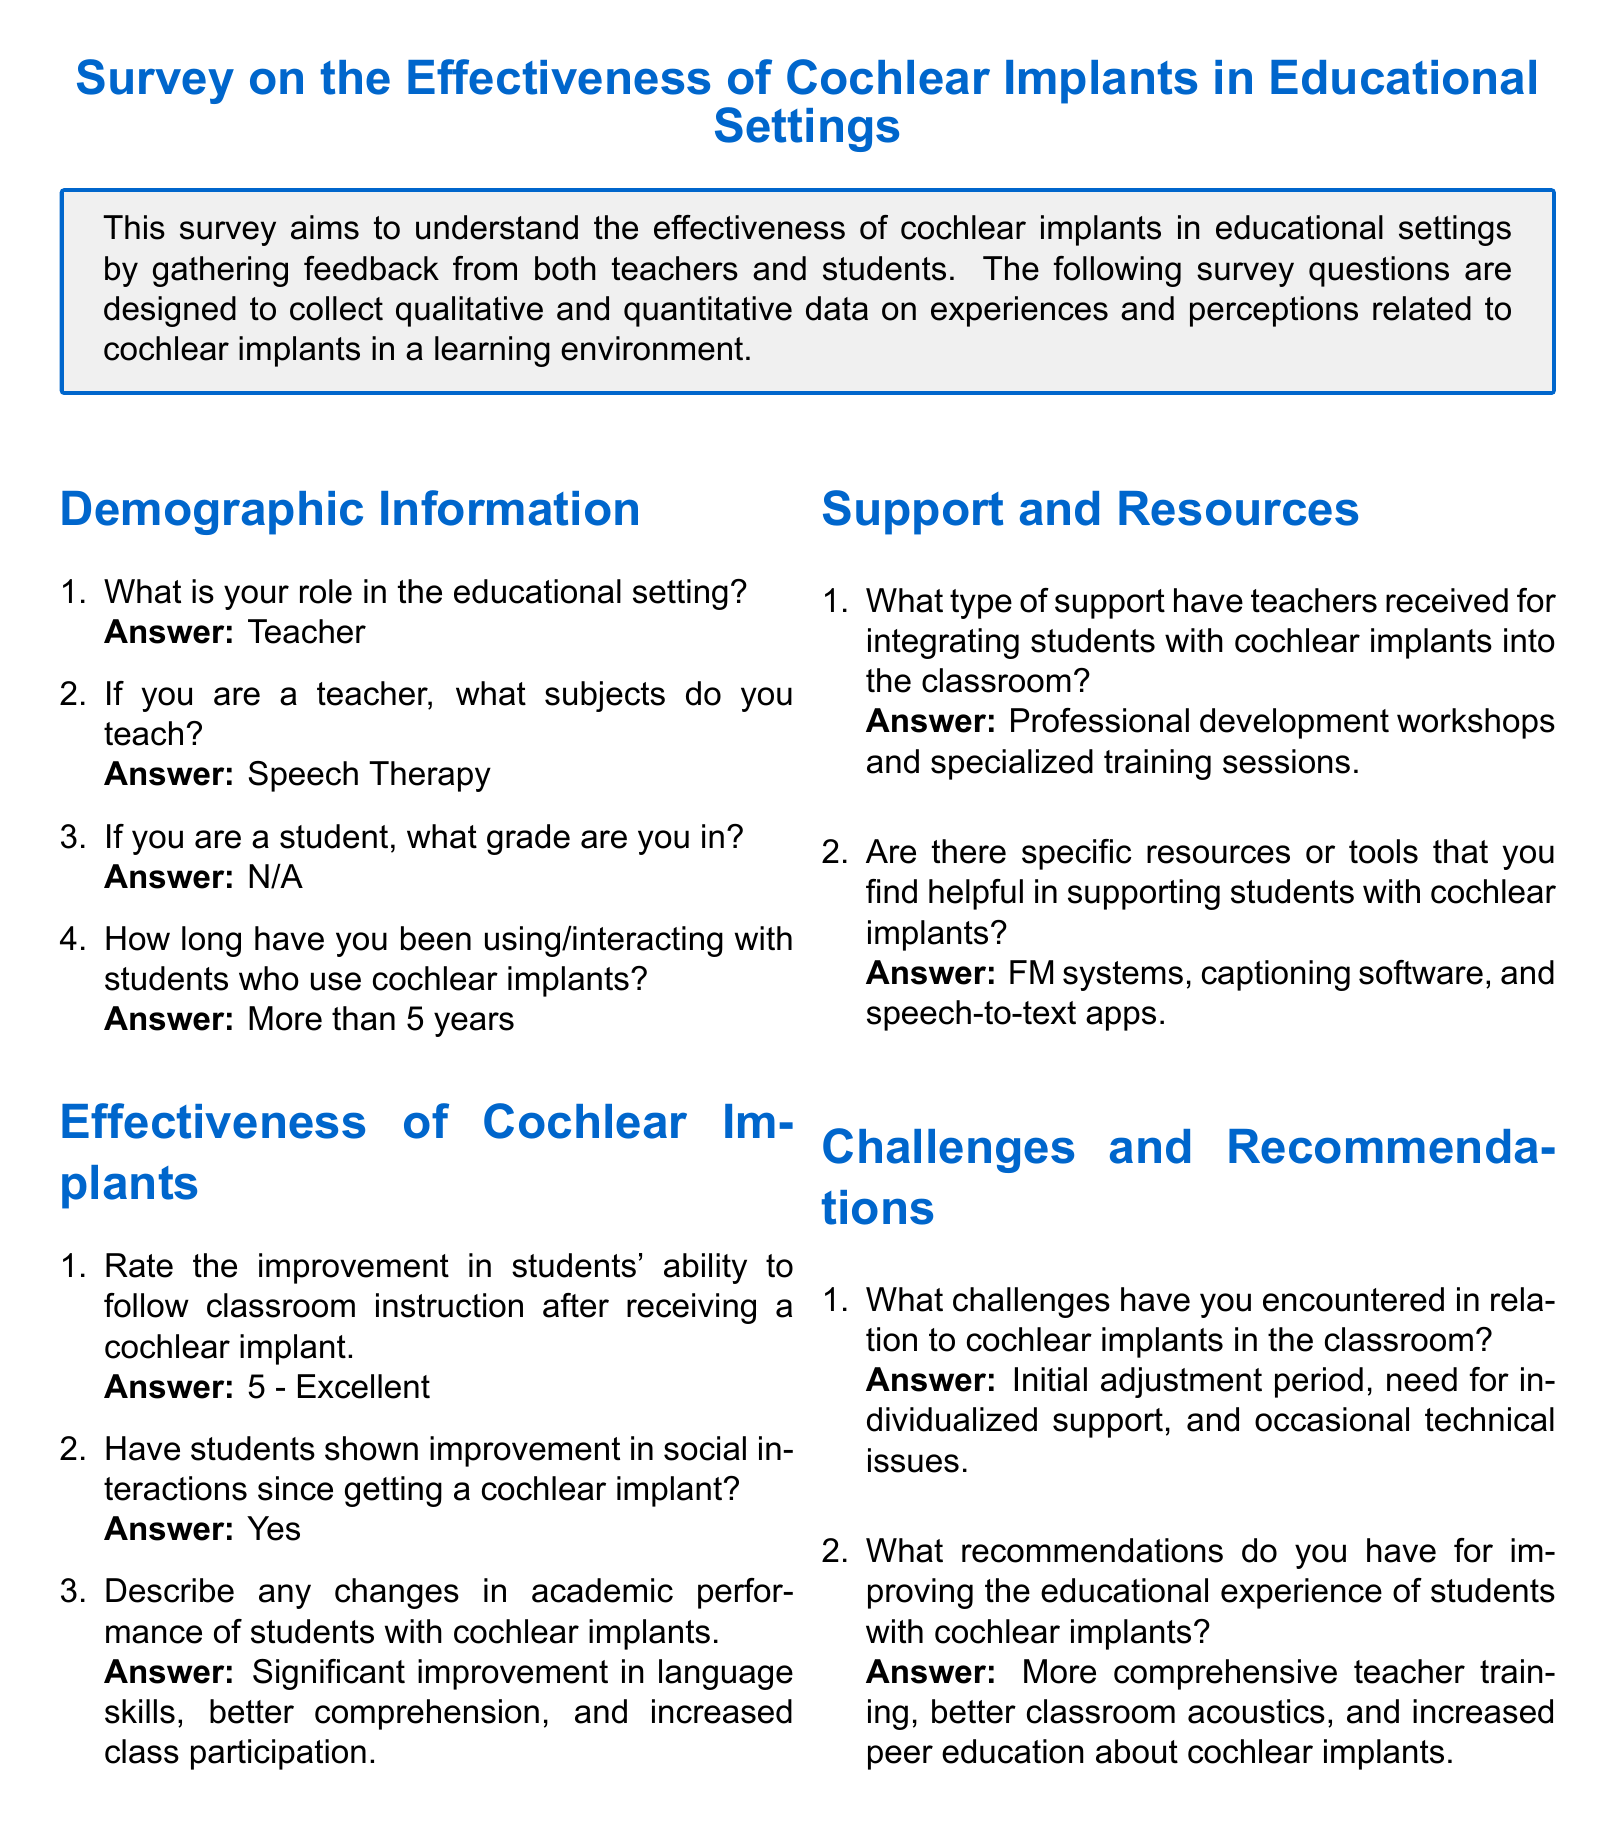What is the role of the respondent in the educational setting? The document states that the respondent's role is specified in the demographic section of the survey.
Answer: Teacher What subject does the respondent teach? This information is provided in the demographic section where the respondent was asked about their teaching subjects.
Answer: Speech Therapy How long has the respondent been using/interacting with students who use cochlear implants? The document includes this information in the demographic section, indicating the duration of interaction with cochlear implant users.
Answer: More than 5 years What rating did the respondent give for improvement in ability to follow classroom instruction? The effectiveness section of the survey includes a response that indicates the level of improvement.
Answer: 5 - Excellent Did students show improvement in social interactions after receiving cochlear implants? The effectiveness section poses a question about social interactions, and the answer reflects the respondent's observation.
Answer: Yes What type of support have teachers received for integrating students with cochlear implants? This information is found in the support and resources section, where the respondent described their support experiences.
Answer: Professional development workshops and specialized training sessions What challenges has the respondent encountered in relation to cochlear implants? This is outlined in the challenges and recommendations section where respondents describe their difficulties.
Answer: Initial adjustment period, need for individualized support, and occasional technical issues What recommendation does the respondent have for improving the experience of students with cochlear implants? The challenges and recommendations section provides insights into suggestions made by the respondent.
Answer: More comprehensive teacher training, better classroom acoustics, and increased peer education about cochlear implants 